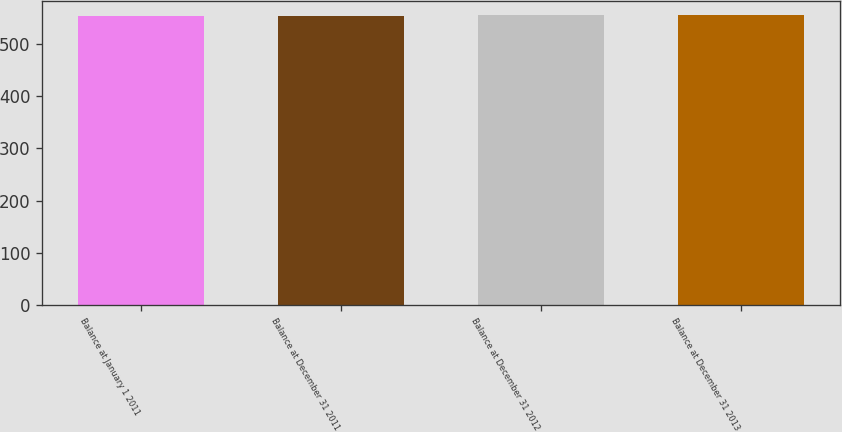Convert chart. <chart><loc_0><loc_0><loc_500><loc_500><bar_chart><fcel>Balance at January 1 2011<fcel>Balance at December 31 2011<fcel>Balance at December 31 2012<fcel>Balance at December 31 2013<nl><fcel>553.9<fcel>554.3<fcel>554.6<fcel>554.8<nl></chart> 